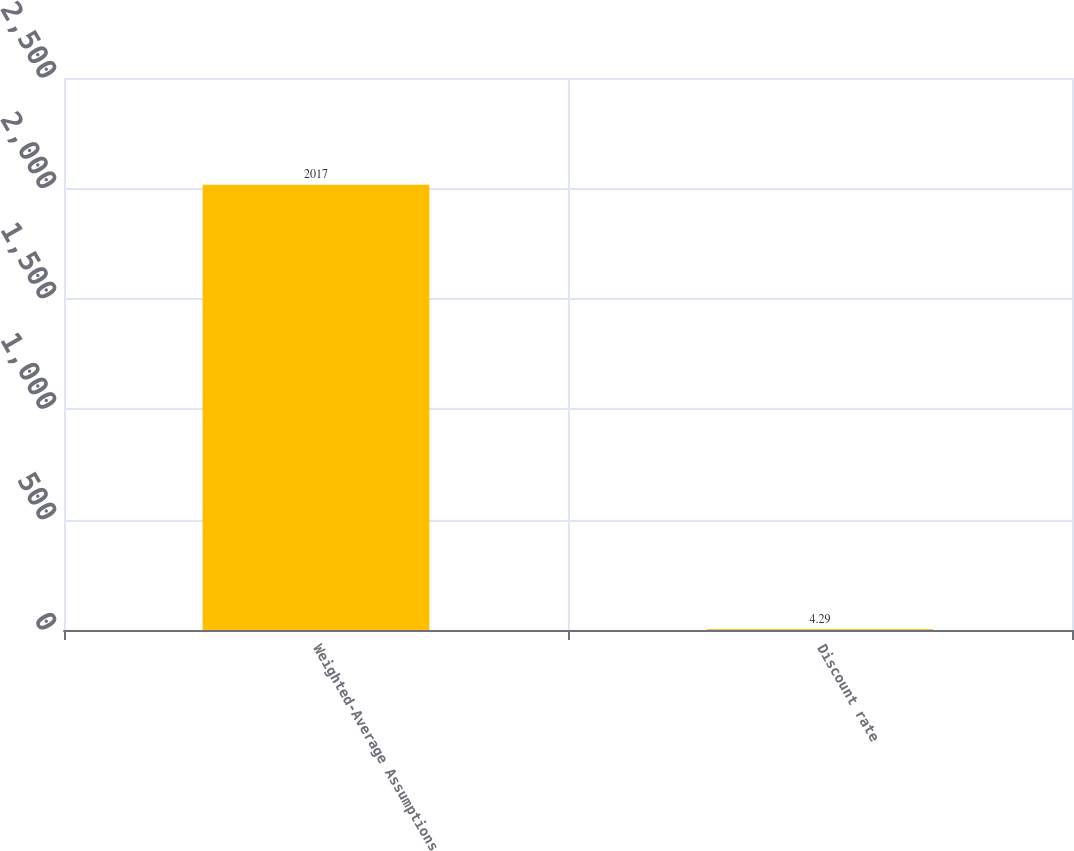Convert chart. <chart><loc_0><loc_0><loc_500><loc_500><bar_chart><fcel>Weighted-Average Assumptions<fcel>Discount rate<nl><fcel>2017<fcel>4.29<nl></chart> 